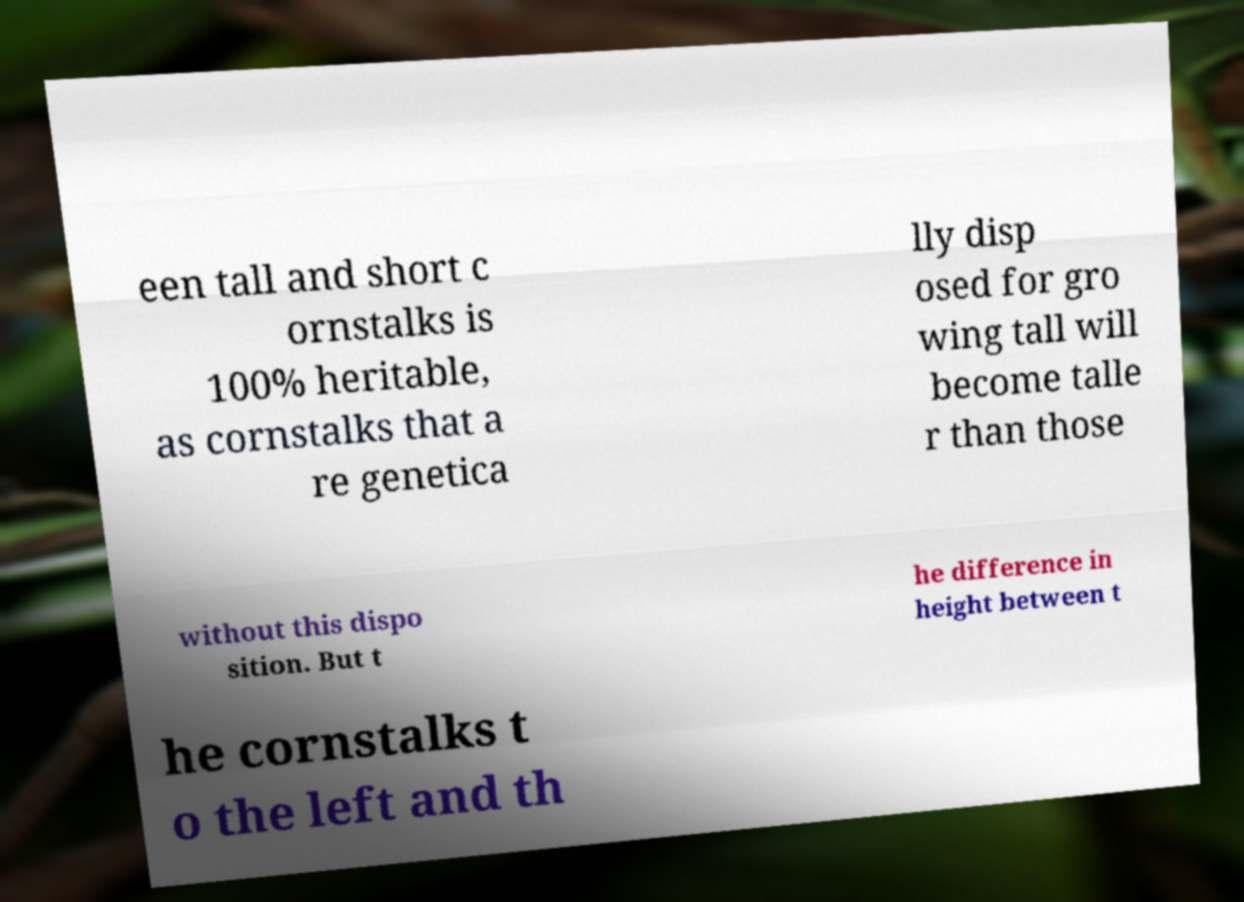What messages or text are displayed in this image? I need them in a readable, typed format. een tall and short c ornstalks is 100% heritable, as cornstalks that a re genetica lly disp osed for gro wing tall will become talle r than those without this dispo sition. But t he difference in height between t he cornstalks t o the left and th 